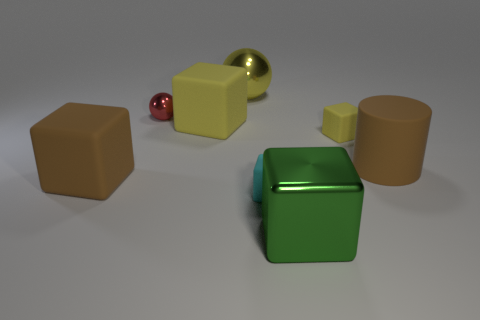How many yellow cubes must be subtracted to get 1 yellow cubes? 1 Add 2 yellow spheres. How many objects exist? 10 Subtract all cyan rubber blocks. How many blocks are left? 4 Subtract all balls. How many objects are left? 6 Subtract all blue cylinders. How many yellow blocks are left? 2 Add 7 red metallic things. How many red metallic things are left? 8 Add 3 purple rubber objects. How many purple rubber objects exist? 3 Subtract all yellow blocks. How many blocks are left? 3 Subtract 1 brown cylinders. How many objects are left? 7 Subtract 1 cylinders. How many cylinders are left? 0 